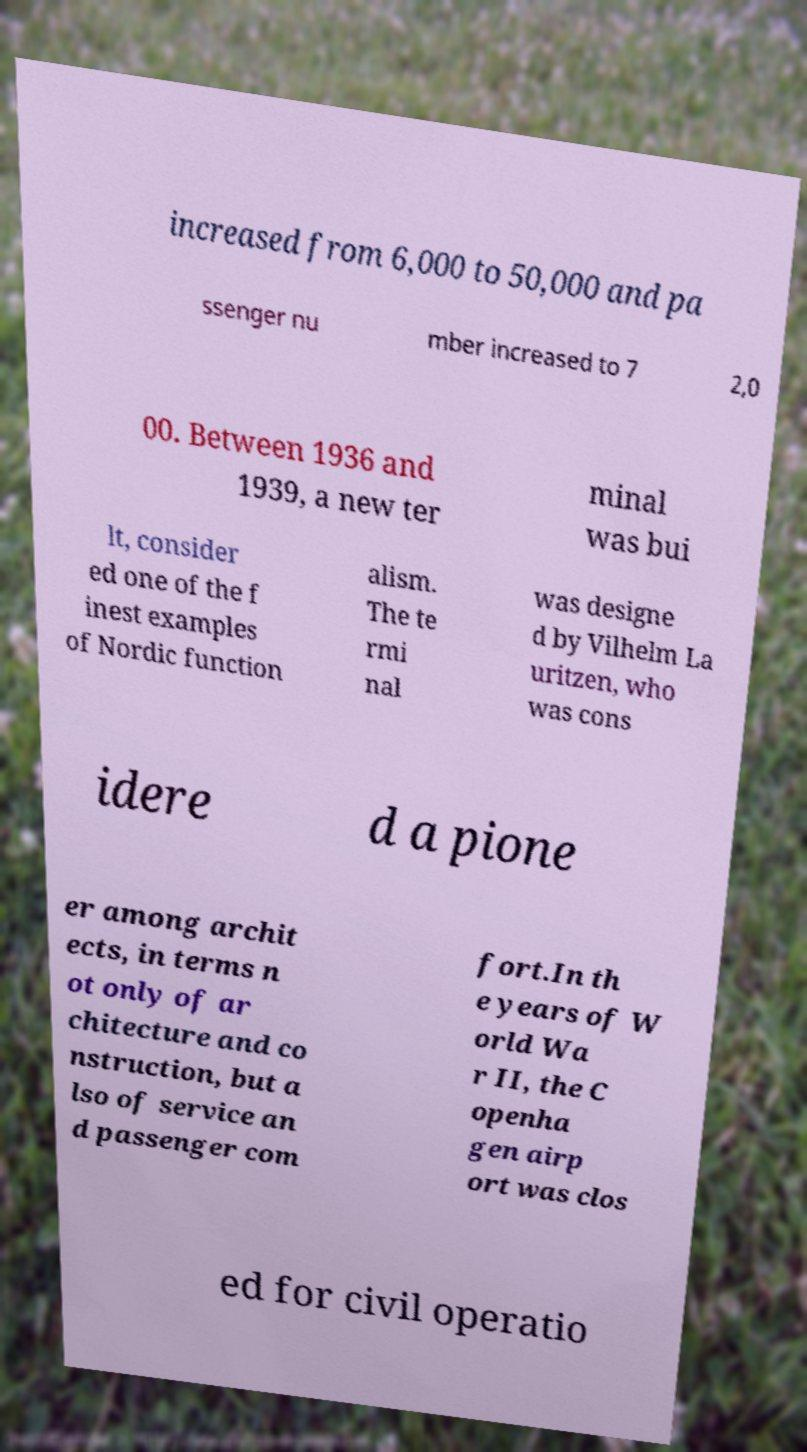For documentation purposes, I need the text within this image transcribed. Could you provide that? increased from 6,000 to 50,000 and pa ssenger nu mber increased to 7 2,0 00. Between 1936 and 1939, a new ter minal was bui lt, consider ed one of the f inest examples of Nordic function alism. The te rmi nal was designe d by Vilhelm La uritzen, who was cons idere d a pione er among archit ects, in terms n ot only of ar chitecture and co nstruction, but a lso of service an d passenger com fort.In th e years of W orld Wa r II, the C openha gen airp ort was clos ed for civil operatio 